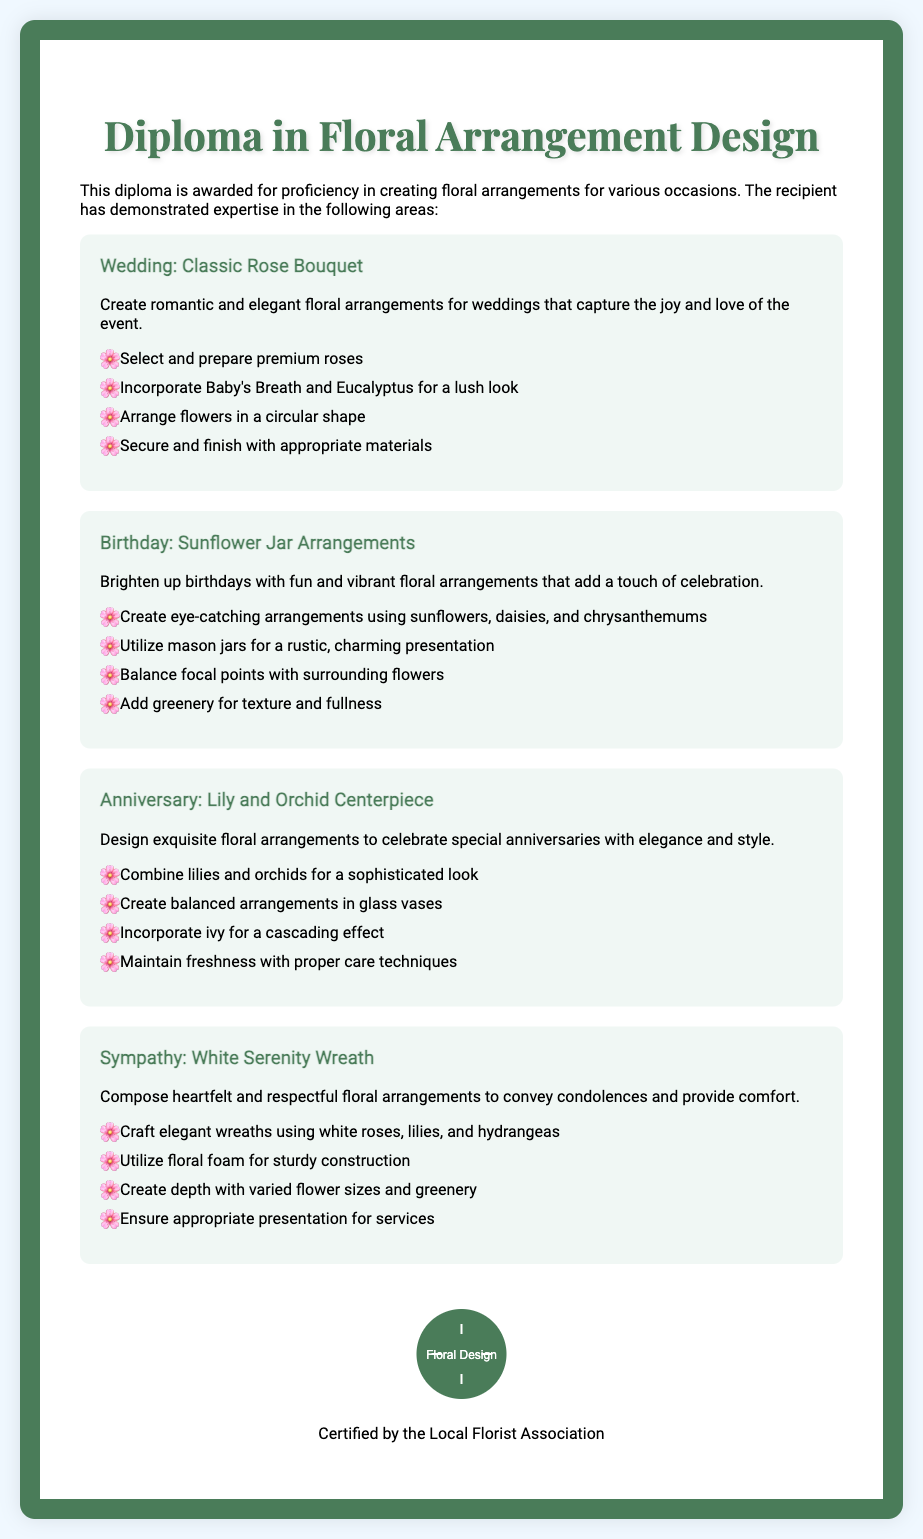What is the title of the diploma? The title of the diploma is prominently displayed at the top of the document.
Answer: Diploma in Floral Arrangement Design How many occasions are covered in the document? The document presents floral arrangements for four distinct occasions.
Answer: Four What flowers are suggested for a wedding arrangement? The details provided in the wedding section list specific flowers for the arrangement.
Answer: Roses What is one additional element for the wedding bouquet? The document mentions an additional floral element to enhance the arrangement.
Answer: Eucalyptus What type of container is used for birthday arrangements? The birthday arrangement specifies a particular type of container for presentation.
Answer: Mason jars What color flowers are used in the sympathy arrangement? The sympathy arrangement describes the color of the featured flowers.
Answer: White What is the main flower for the anniversary arrangement? The main flower highlighted in the anniversary section is clearly stated.
Answer: Lily What should be incorporated for texture in birthday arrangements? The document provides guidance on adding texture to birthday arrangements.
Answer: Greenery Who certifies the diploma? The bottom of the document includes information about the certifying body.
Answer: Local Florist Association 